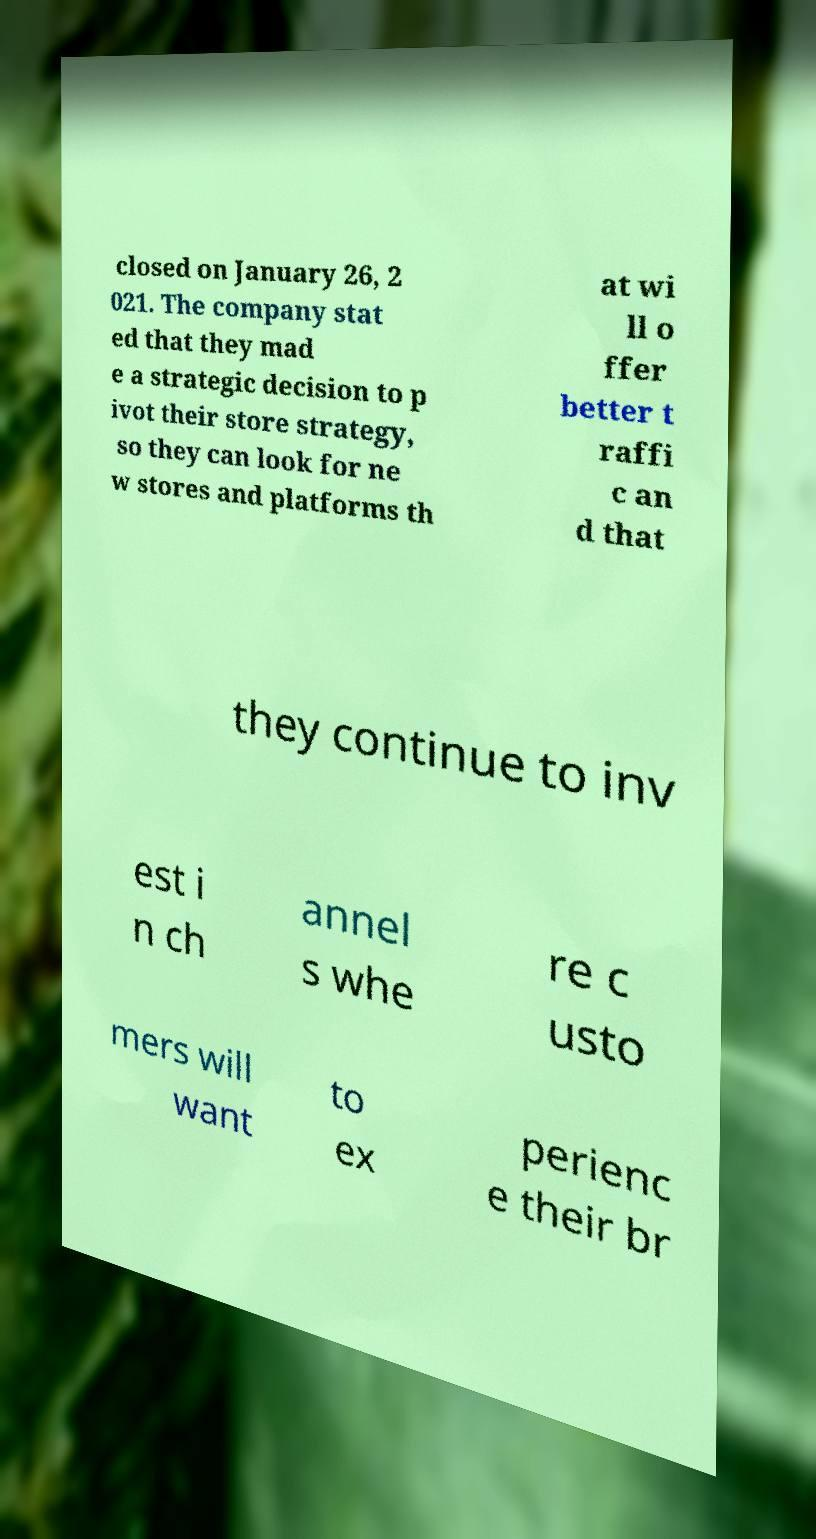Please identify and transcribe the text found in this image. closed on January 26, 2 021. The company stat ed that they mad e a strategic decision to p ivot their store strategy, so they can look for ne w stores and platforms th at wi ll o ffer better t raffi c an d that they continue to inv est i n ch annel s whe re c usto mers will want to ex perienc e their br 